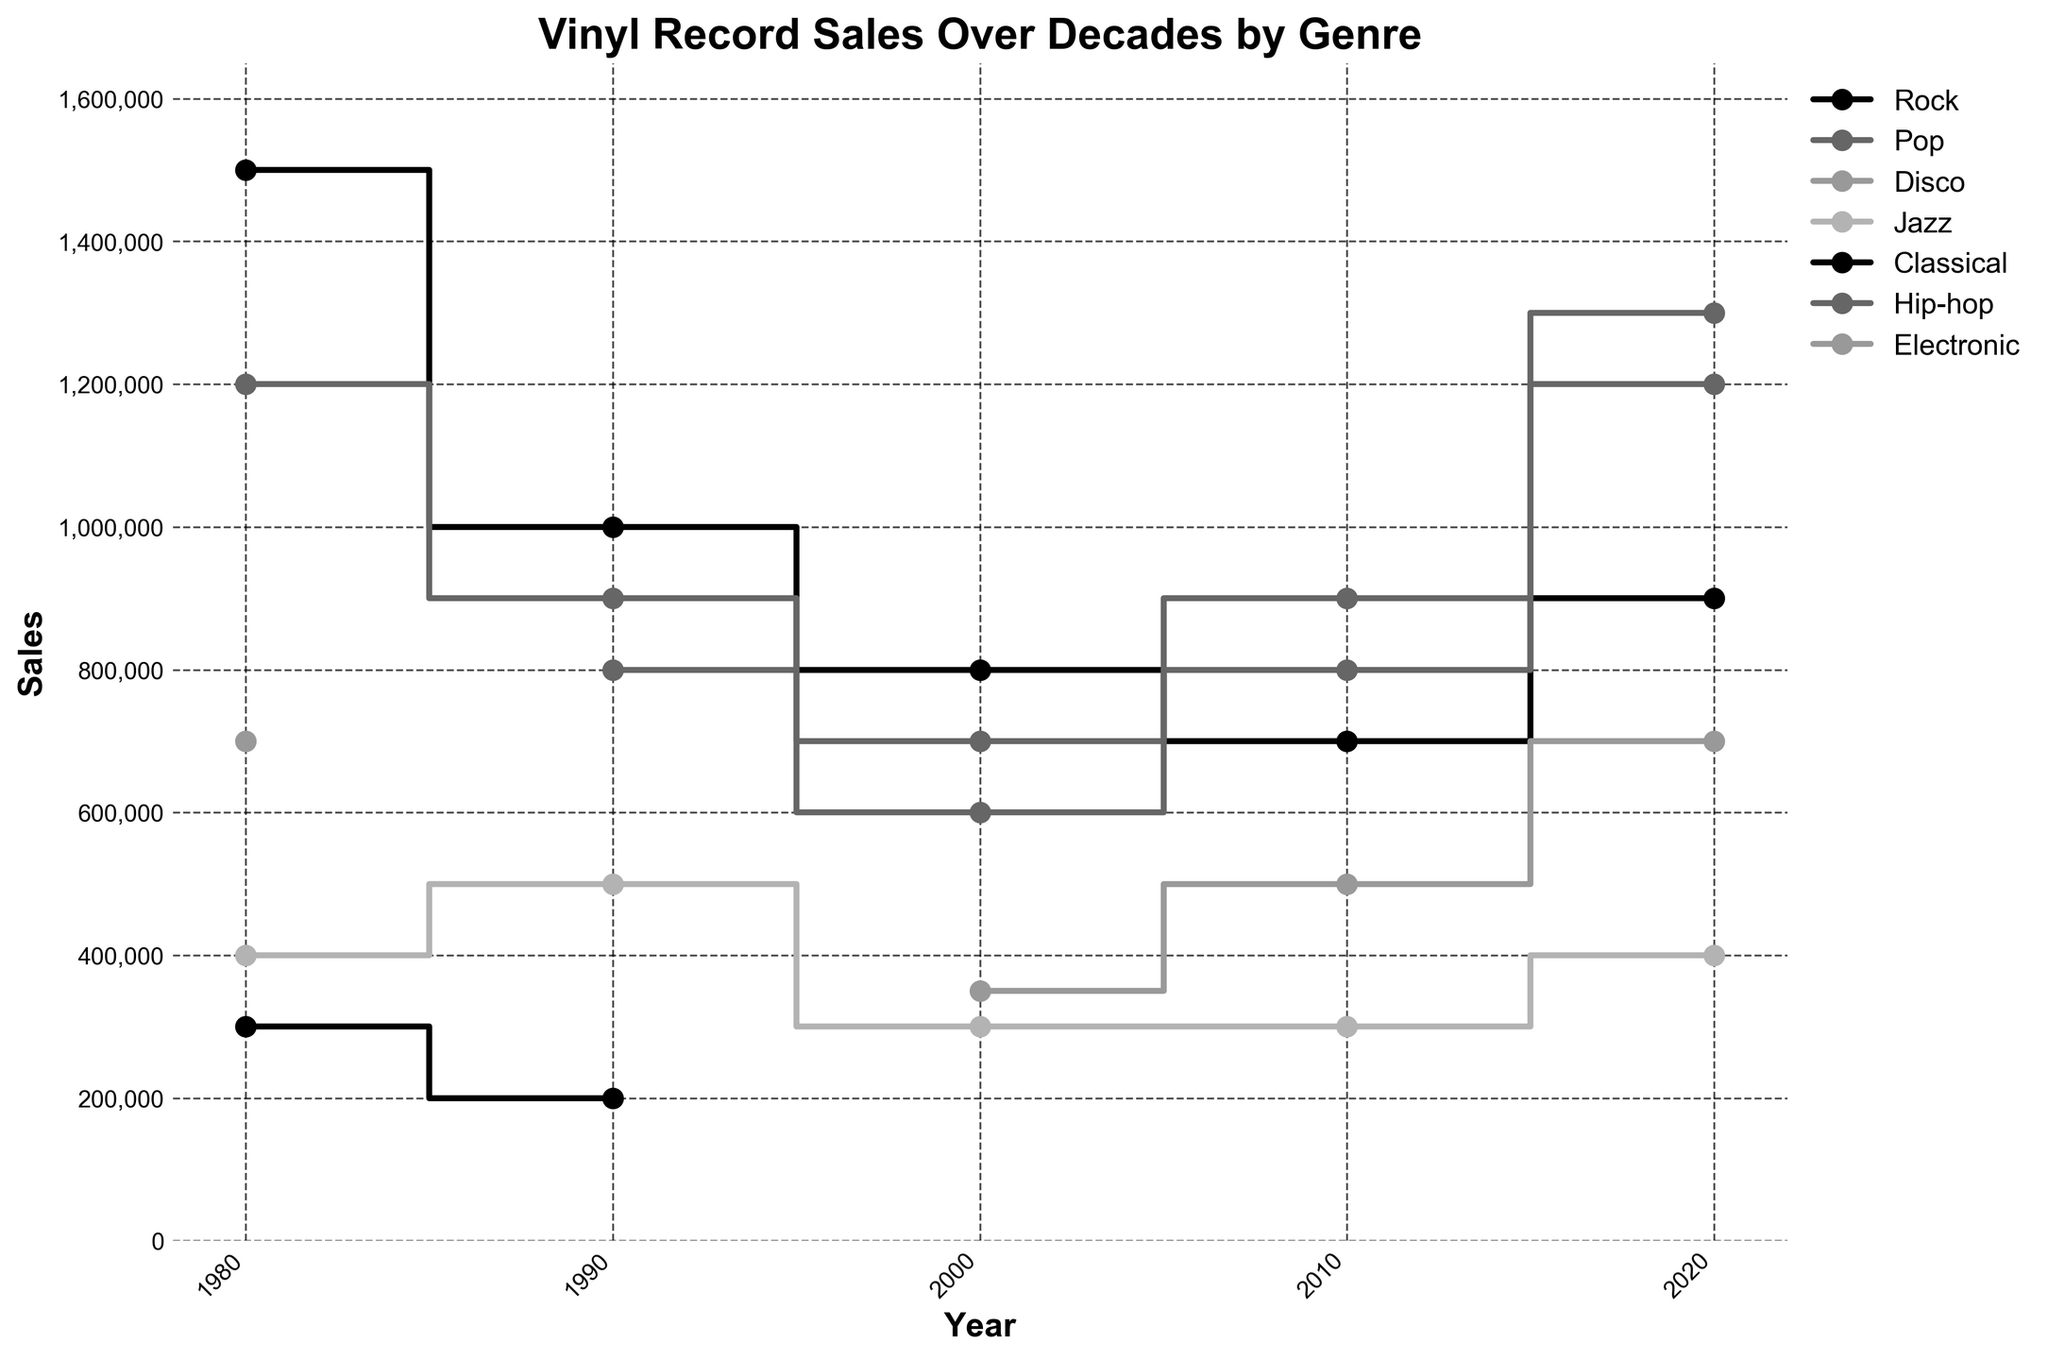What is the title of the plot? The title is typically found at the top of the plot, and it usually provides a summary of what the plot is about.
Answer: Vinyl Record Sales Over Decades by Genre Which genre had the highest sales in 1980? To find this, look at the y-values of the stair plot corresponding to the year 1980 and compare the heights. The genre with the highest y-value represents the highest sales.
Answer: Rock By how much did Hip-hop sales change from 1990 to 2020? Check the y-values for Hip-hop in 1990 and 2020 and subtract the value for 1990 from the value for 2020. In 1990, Hip-hop sales were 800,000. In 2020, Hip-hop sales were 1,300,000. Calculate the difference: 1,300,000 - 800,000 = 500,000.
Answer: 500,000 Which genres were introduced into the chart after 1980? Identify genres that first appear in the plot in years after 1980. Hip-hop appears first in 1990, and Electronic appears first in 2000.
Answer: Hip-hop, Electronic How do Rock and Pop sales in 2010 compare? Look at the y-values for both Rock and Pop in the year 2010. Rock sales are 700,000, and Pop sales are 800,000. Pop sales are greater than Rock sales in 2010.
Answer: Pop > Rock What was the total sales for Jazz across all plotted years? Calculate the sum of Jazz sales for each year represented in the plot. Jazz sales in 1980: 400,000; in 1990: 500,000; in 2000: 300,000; in 2010: 300,000; in 2020: 400,000. The total is 400,000 + 500,000 + 300,000 + 300,000 + 400,000 = 1,900,000.
Answer: 1,900,000 Which genre shows a declining trend from 1980 to 2020? Examine each genre's sales over the years and check if the values are consistently decreasing. Rock sales go from 1,500,000 in 1980 to 900,000 in 2020, indicating a decline.
Answer: Rock What is the range of Pop sales across all decades? Identify the minimum and maximum sales for Pop across all plotted years. The minimum sales for Pop are 600,000 in 2000, and the maximum sales are 1,200,000 in 1980 and 2020. The range is 1,200,000 - 600,000 = 600,000.
Answer: 600,000 In which decade did Electronic sales surpass Jazz sales? Compare the steps for Electronic and Jazz for each year starting from 2000 since Electronic was introduced then. The decade is 2010, where Electronic sales (500,000) are higher than Jazz sales (300,000).
Answer: 2010 Which genre had no sales representation in the 1980 data? Look at the genres listed for 1980 and note any missing genres that appear in later years. Hip-hop and Electronic are missing in 1980.
Answer: Hip-hop, Electronic 